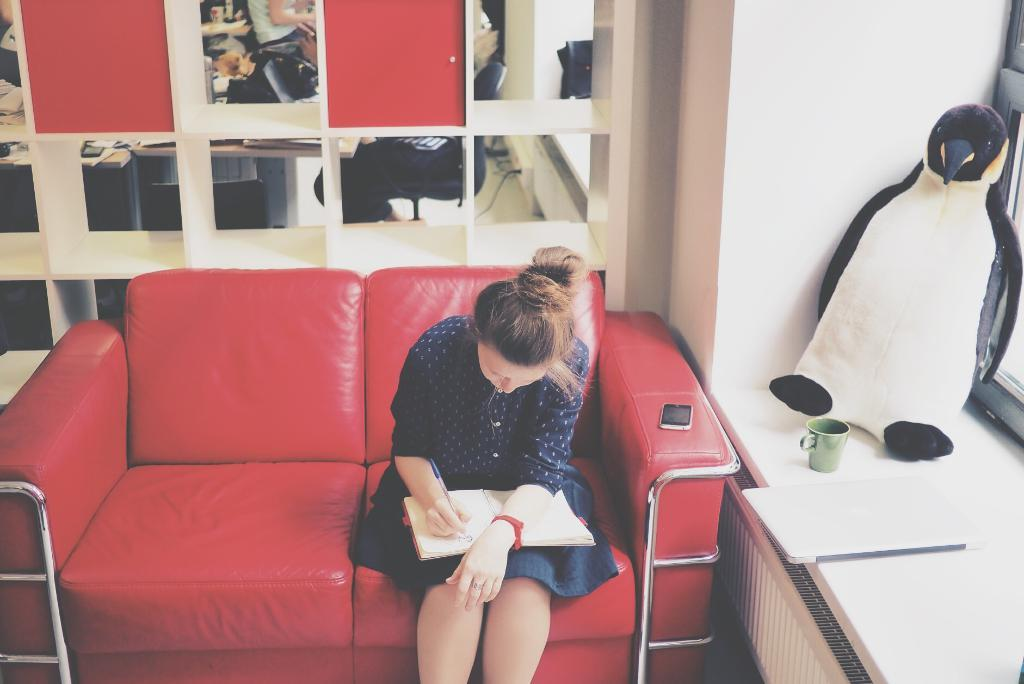Who is the main subject in the image? There is a woman in the image. What is the woman doing in the image? The woman is writing on a book. Where is the woman sitting in the image? The woman is sitting on a red couch. What else can be seen on the couch? There is a mobile on the couch. What is visible through the window in the image? There is a toy, a cup, and a laptop in front of the window. How many bulbs are present in the image? There are no bulbs visible in the image. What type of lumber is being used to construct the couch in the image? The image does not provide information about the materials used to construct the couch. 